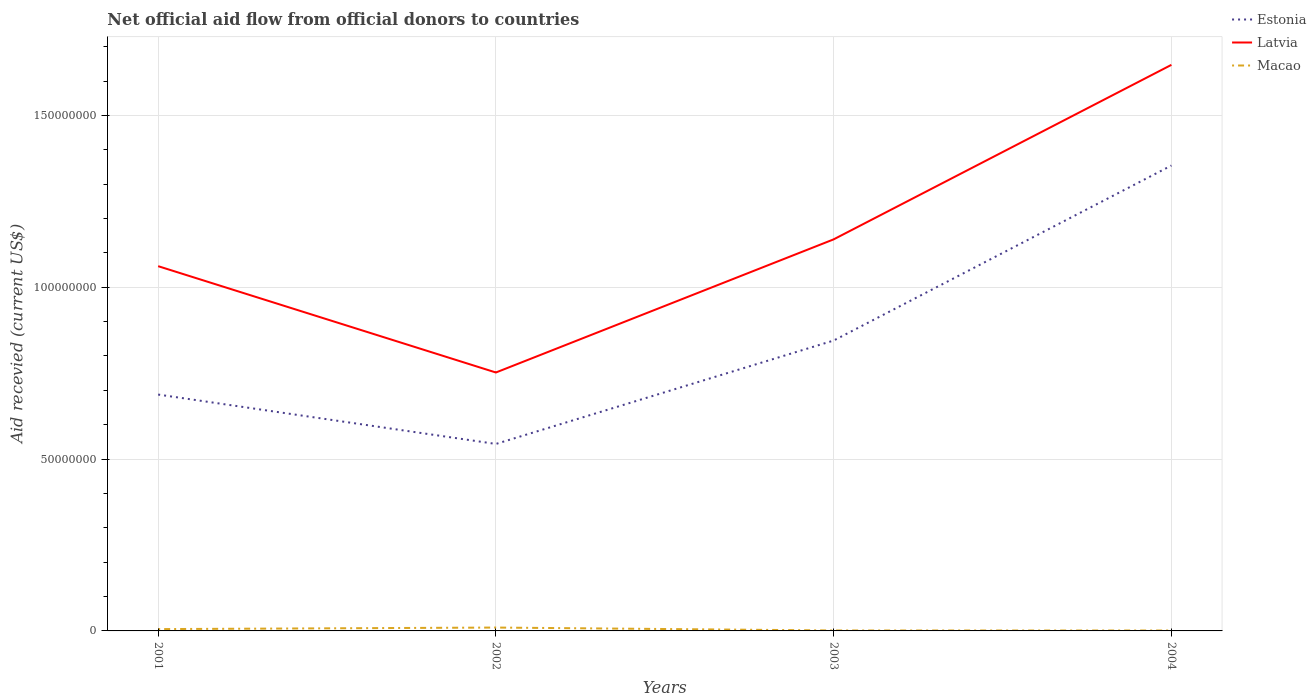Is the number of lines equal to the number of legend labels?
Your answer should be compact. Yes. Across all years, what is the maximum total aid received in Estonia?
Your answer should be compact. 5.44e+07. In which year was the total aid received in Estonia maximum?
Your answer should be compact. 2002. What is the total total aid received in Estonia in the graph?
Offer a very short reply. -3.01e+07. What is the difference between the highest and the second highest total aid received in Latvia?
Your response must be concise. 8.95e+07. What is the difference between the highest and the lowest total aid received in Estonia?
Ensure brevity in your answer.  1. Are the values on the major ticks of Y-axis written in scientific E-notation?
Give a very brief answer. No. Does the graph contain any zero values?
Make the answer very short. No. Does the graph contain grids?
Your response must be concise. Yes. Where does the legend appear in the graph?
Offer a very short reply. Top right. How many legend labels are there?
Offer a terse response. 3. What is the title of the graph?
Provide a succinct answer. Net official aid flow from official donors to countries. What is the label or title of the X-axis?
Keep it short and to the point. Years. What is the label or title of the Y-axis?
Your answer should be very brief. Aid recevied (current US$). What is the Aid recevied (current US$) in Estonia in 2001?
Offer a very short reply. 6.88e+07. What is the Aid recevied (current US$) in Latvia in 2001?
Your answer should be very brief. 1.06e+08. What is the Aid recevied (current US$) of Macao in 2001?
Give a very brief answer. 5.30e+05. What is the Aid recevied (current US$) of Estonia in 2002?
Keep it short and to the point. 5.44e+07. What is the Aid recevied (current US$) in Latvia in 2002?
Provide a succinct answer. 7.52e+07. What is the Aid recevied (current US$) in Macao in 2002?
Provide a succinct answer. 9.80e+05. What is the Aid recevied (current US$) of Estonia in 2003?
Your answer should be compact. 8.45e+07. What is the Aid recevied (current US$) of Latvia in 2003?
Provide a succinct answer. 1.14e+08. What is the Aid recevied (current US$) of Estonia in 2004?
Provide a succinct answer. 1.35e+08. What is the Aid recevied (current US$) of Latvia in 2004?
Provide a short and direct response. 1.65e+08. What is the Aid recevied (current US$) of Macao in 2004?
Make the answer very short. 1.20e+05. Across all years, what is the maximum Aid recevied (current US$) of Estonia?
Provide a short and direct response. 1.35e+08. Across all years, what is the maximum Aid recevied (current US$) in Latvia?
Your response must be concise. 1.65e+08. Across all years, what is the maximum Aid recevied (current US$) in Macao?
Your response must be concise. 9.80e+05. Across all years, what is the minimum Aid recevied (current US$) in Estonia?
Give a very brief answer. 5.44e+07. Across all years, what is the minimum Aid recevied (current US$) in Latvia?
Your response must be concise. 7.52e+07. What is the total Aid recevied (current US$) of Estonia in the graph?
Your response must be concise. 3.43e+08. What is the total Aid recevied (current US$) in Latvia in the graph?
Ensure brevity in your answer.  4.60e+08. What is the total Aid recevied (current US$) in Macao in the graph?
Keep it short and to the point. 1.76e+06. What is the difference between the Aid recevied (current US$) in Estonia in 2001 and that in 2002?
Your response must be concise. 1.44e+07. What is the difference between the Aid recevied (current US$) of Latvia in 2001 and that in 2002?
Offer a very short reply. 3.09e+07. What is the difference between the Aid recevied (current US$) of Macao in 2001 and that in 2002?
Offer a very short reply. -4.50e+05. What is the difference between the Aid recevied (current US$) in Estonia in 2001 and that in 2003?
Your answer should be very brief. -1.57e+07. What is the difference between the Aid recevied (current US$) of Latvia in 2001 and that in 2003?
Provide a succinct answer. -7.80e+06. What is the difference between the Aid recevied (current US$) of Macao in 2001 and that in 2003?
Offer a terse response. 4.00e+05. What is the difference between the Aid recevied (current US$) in Estonia in 2001 and that in 2004?
Ensure brevity in your answer.  -6.66e+07. What is the difference between the Aid recevied (current US$) in Latvia in 2001 and that in 2004?
Provide a short and direct response. -5.86e+07. What is the difference between the Aid recevied (current US$) of Estonia in 2002 and that in 2003?
Ensure brevity in your answer.  -3.01e+07. What is the difference between the Aid recevied (current US$) in Latvia in 2002 and that in 2003?
Your answer should be very brief. -3.87e+07. What is the difference between the Aid recevied (current US$) in Macao in 2002 and that in 2003?
Provide a short and direct response. 8.50e+05. What is the difference between the Aid recevied (current US$) in Estonia in 2002 and that in 2004?
Provide a succinct answer. -8.10e+07. What is the difference between the Aid recevied (current US$) of Latvia in 2002 and that in 2004?
Your response must be concise. -8.95e+07. What is the difference between the Aid recevied (current US$) of Macao in 2002 and that in 2004?
Your response must be concise. 8.60e+05. What is the difference between the Aid recevied (current US$) of Estonia in 2003 and that in 2004?
Your answer should be compact. -5.09e+07. What is the difference between the Aid recevied (current US$) in Latvia in 2003 and that in 2004?
Offer a terse response. -5.08e+07. What is the difference between the Aid recevied (current US$) of Macao in 2003 and that in 2004?
Offer a very short reply. 10000. What is the difference between the Aid recevied (current US$) of Estonia in 2001 and the Aid recevied (current US$) of Latvia in 2002?
Offer a terse response. -6.42e+06. What is the difference between the Aid recevied (current US$) in Estonia in 2001 and the Aid recevied (current US$) in Macao in 2002?
Offer a very short reply. 6.78e+07. What is the difference between the Aid recevied (current US$) of Latvia in 2001 and the Aid recevied (current US$) of Macao in 2002?
Your answer should be compact. 1.05e+08. What is the difference between the Aid recevied (current US$) of Estonia in 2001 and the Aid recevied (current US$) of Latvia in 2003?
Your answer should be compact. -4.52e+07. What is the difference between the Aid recevied (current US$) in Estonia in 2001 and the Aid recevied (current US$) in Macao in 2003?
Your response must be concise. 6.86e+07. What is the difference between the Aid recevied (current US$) of Latvia in 2001 and the Aid recevied (current US$) of Macao in 2003?
Your response must be concise. 1.06e+08. What is the difference between the Aid recevied (current US$) in Estonia in 2001 and the Aid recevied (current US$) in Latvia in 2004?
Keep it short and to the point. -9.59e+07. What is the difference between the Aid recevied (current US$) of Estonia in 2001 and the Aid recevied (current US$) of Macao in 2004?
Ensure brevity in your answer.  6.87e+07. What is the difference between the Aid recevied (current US$) of Latvia in 2001 and the Aid recevied (current US$) of Macao in 2004?
Keep it short and to the point. 1.06e+08. What is the difference between the Aid recevied (current US$) of Estonia in 2002 and the Aid recevied (current US$) of Latvia in 2003?
Offer a very short reply. -5.95e+07. What is the difference between the Aid recevied (current US$) in Estonia in 2002 and the Aid recevied (current US$) in Macao in 2003?
Ensure brevity in your answer.  5.43e+07. What is the difference between the Aid recevied (current US$) of Latvia in 2002 and the Aid recevied (current US$) of Macao in 2003?
Your answer should be very brief. 7.51e+07. What is the difference between the Aid recevied (current US$) in Estonia in 2002 and the Aid recevied (current US$) in Latvia in 2004?
Give a very brief answer. -1.10e+08. What is the difference between the Aid recevied (current US$) in Estonia in 2002 and the Aid recevied (current US$) in Macao in 2004?
Your answer should be compact. 5.43e+07. What is the difference between the Aid recevied (current US$) in Latvia in 2002 and the Aid recevied (current US$) in Macao in 2004?
Offer a very short reply. 7.51e+07. What is the difference between the Aid recevied (current US$) in Estonia in 2003 and the Aid recevied (current US$) in Latvia in 2004?
Offer a terse response. -8.02e+07. What is the difference between the Aid recevied (current US$) in Estonia in 2003 and the Aid recevied (current US$) in Macao in 2004?
Your response must be concise. 8.44e+07. What is the difference between the Aid recevied (current US$) of Latvia in 2003 and the Aid recevied (current US$) of Macao in 2004?
Provide a short and direct response. 1.14e+08. What is the average Aid recevied (current US$) in Estonia per year?
Your answer should be compact. 8.58e+07. What is the average Aid recevied (current US$) of Latvia per year?
Make the answer very short. 1.15e+08. What is the average Aid recevied (current US$) of Macao per year?
Make the answer very short. 4.40e+05. In the year 2001, what is the difference between the Aid recevied (current US$) of Estonia and Aid recevied (current US$) of Latvia?
Your answer should be compact. -3.74e+07. In the year 2001, what is the difference between the Aid recevied (current US$) in Estonia and Aid recevied (current US$) in Macao?
Your response must be concise. 6.82e+07. In the year 2001, what is the difference between the Aid recevied (current US$) of Latvia and Aid recevied (current US$) of Macao?
Keep it short and to the point. 1.06e+08. In the year 2002, what is the difference between the Aid recevied (current US$) in Estonia and Aid recevied (current US$) in Latvia?
Provide a succinct answer. -2.08e+07. In the year 2002, what is the difference between the Aid recevied (current US$) of Estonia and Aid recevied (current US$) of Macao?
Your response must be concise. 5.34e+07. In the year 2002, what is the difference between the Aid recevied (current US$) of Latvia and Aid recevied (current US$) of Macao?
Your answer should be very brief. 7.42e+07. In the year 2003, what is the difference between the Aid recevied (current US$) in Estonia and Aid recevied (current US$) in Latvia?
Provide a short and direct response. -2.94e+07. In the year 2003, what is the difference between the Aid recevied (current US$) of Estonia and Aid recevied (current US$) of Macao?
Your answer should be compact. 8.44e+07. In the year 2003, what is the difference between the Aid recevied (current US$) in Latvia and Aid recevied (current US$) in Macao?
Offer a terse response. 1.14e+08. In the year 2004, what is the difference between the Aid recevied (current US$) of Estonia and Aid recevied (current US$) of Latvia?
Keep it short and to the point. -2.93e+07. In the year 2004, what is the difference between the Aid recevied (current US$) in Estonia and Aid recevied (current US$) in Macao?
Ensure brevity in your answer.  1.35e+08. In the year 2004, what is the difference between the Aid recevied (current US$) in Latvia and Aid recevied (current US$) in Macao?
Give a very brief answer. 1.65e+08. What is the ratio of the Aid recevied (current US$) in Estonia in 2001 to that in 2002?
Your response must be concise. 1.26. What is the ratio of the Aid recevied (current US$) of Latvia in 2001 to that in 2002?
Provide a short and direct response. 1.41. What is the ratio of the Aid recevied (current US$) of Macao in 2001 to that in 2002?
Ensure brevity in your answer.  0.54. What is the ratio of the Aid recevied (current US$) in Estonia in 2001 to that in 2003?
Offer a terse response. 0.81. What is the ratio of the Aid recevied (current US$) of Latvia in 2001 to that in 2003?
Keep it short and to the point. 0.93. What is the ratio of the Aid recevied (current US$) of Macao in 2001 to that in 2003?
Your answer should be compact. 4.08. What is the ratio of the Aid recevied (current US$) in Estonia in 2001 to that in 2004?
Your answer should be very brief. 0.51. What is the ratio of the Aid recevied (current US$) of Latvia in 2001 to that in 2004?
Offer a terse response. 0.64. What is the ratio of the Aid recevied (current US$) of Macao in 2001 to that in 2004?
Your answer should be very brief. 4.42. What is the ratio of the Aid recevied (current US$) of Estonia in 2002 to that in 2003?
Your answer should be very brief. 0.64. What is the ratio of the Aid recevied (current US$) of Latvia in 2002 to that in 2003?
Offer a very short reply. 0.66. What is the ratio of the Aid recevied (current US$) of Macao in 2002 to that in 2003?
Your answer should be very brief. 7.54. What is the ratio of the Aid recevied (current US$) in Estonia in 2002 to that in 2004?
Your response must be concise. 0.4. What is the ratio of the Aid recevied (current US$) of Latvia in 2002 to that in 2004?
Make the answer very short. 0.46. What is the ratio of the Aid recevied (current US$) of Macao in 2002 to that in 2004?
Your answer should be very brief. 8.17. What is the ratio of the Aid recevied (current US$) in Estonia in 2003 to that in 2004?
Provide a short and direct response. 0.62. What is the ratio of the Aid recevied (current US$) in Latvia in 2003 to that in 2004?
Offer a very short reply. 0.69. What is the ratio of the Aid recevied (current US$) of Macao in 2003 to that in 2004?
Keep it short and to the point. 1.08. What is the difference between the highest and the second highest Aid recevied (current US$) in Estonia?
Your answer should be very brief. 5.09e+07. What is the difference between the highest and the second highest Aid recevied (current US$) of Latvia?
Offer a very short reply. 5.08e+07. What is the difference between the highest and the lowest Aid recevied (current US$) in Estonia?
Provide a short and direct response. 8.10e+07. What is the difference between the highest and the lowest Aid recevied (current US$) of Latvia?
Offer a very short reply. 8.95e+07. What is the difference between the highest and the lowest Aid recevied (current US$) of Macao?
Your response must be concise. 8.60e+05. 